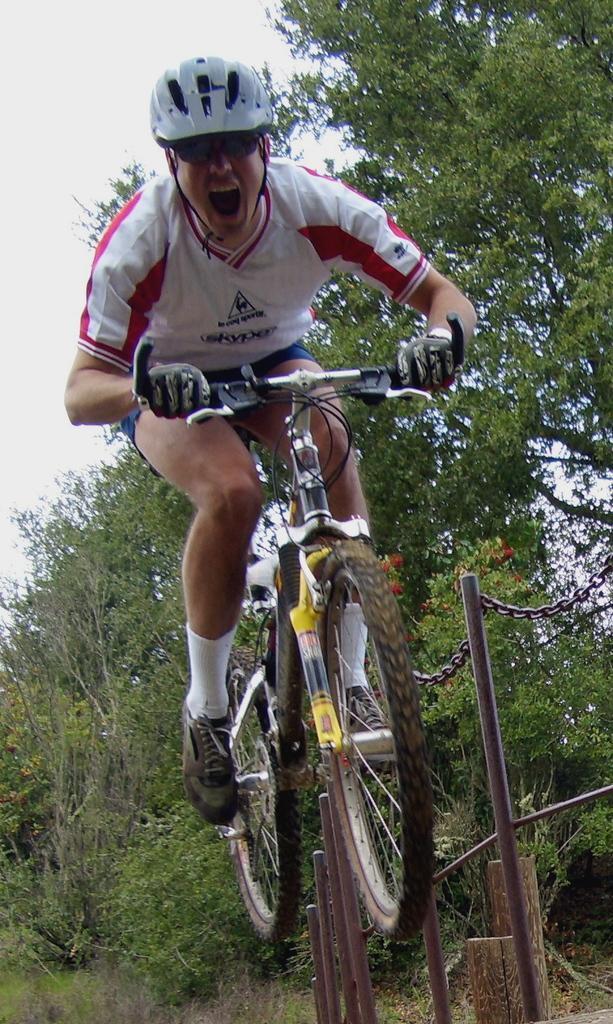Please provide a concise description of this image. In the image we can see a person wearing clothes, helmet, goggles, gloves, socks and shoes. The person is riding on a bicycle, this is a pole and a chain attached to it. There are trees and a sky, this is a grass. 